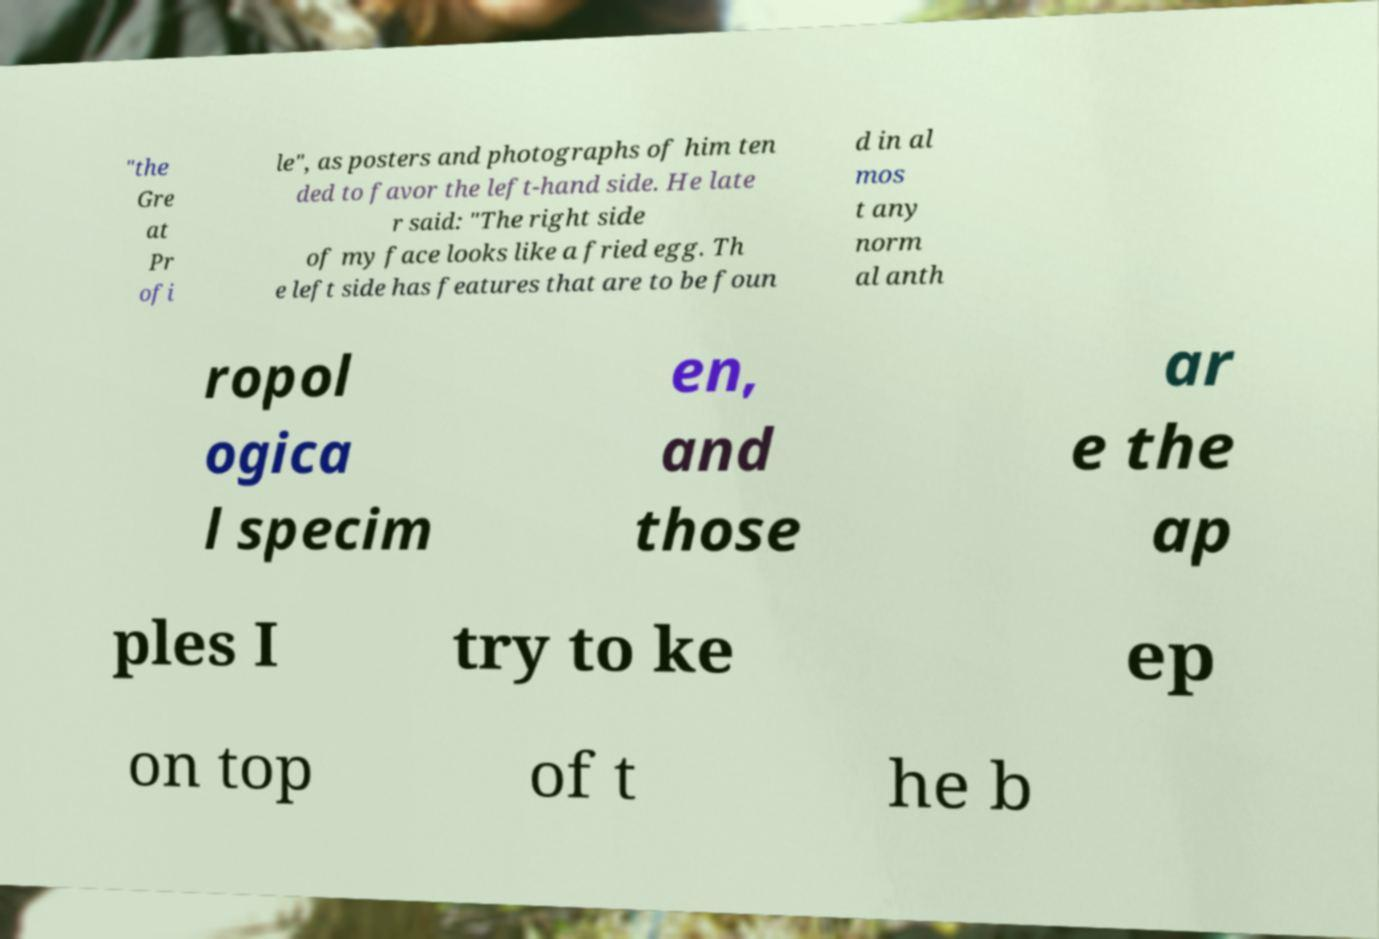Can you read and provide the text displayed in the image?This photo seems to have some interesting text. Can you extract and type it out for me? "the Gre at Pr ofi le", as posters and photographs of him ten ded to favor the left-hand side. He late r said: "The right side of my face looks like a fried egg. Th e left side has features that are to be foun d in al mos t any norm al anth ropol ogica l specim en, and those ar e the ap ples I try to ke ep on top of t he b 